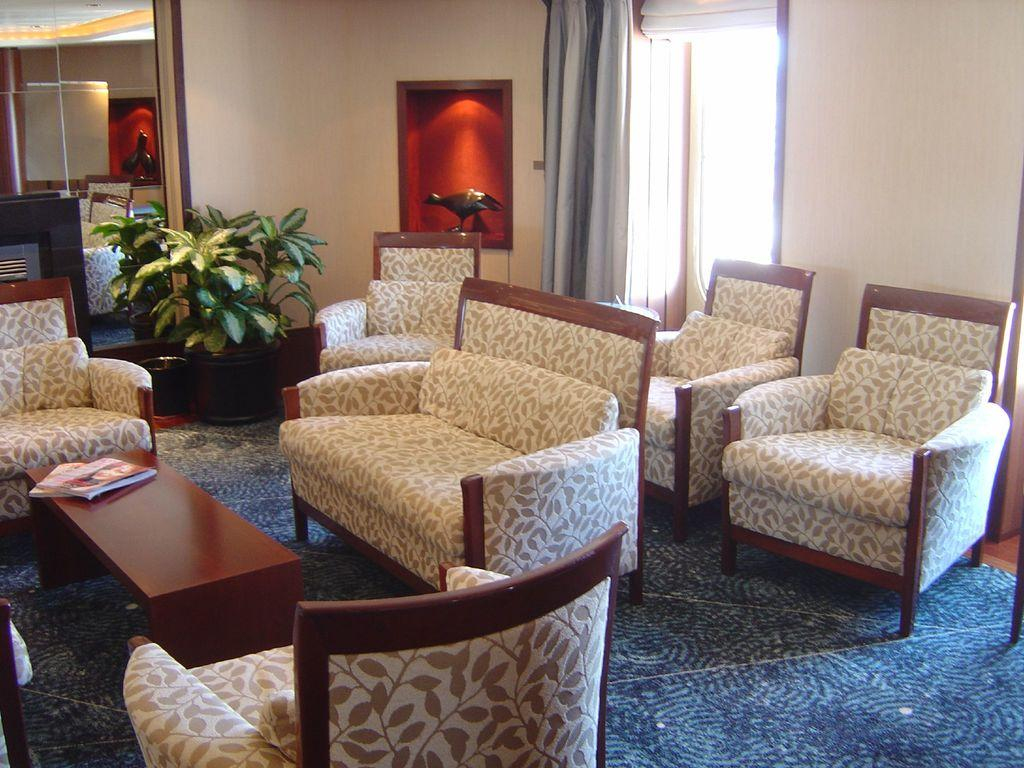What type of furniture is present in the image? There are sofa chairs in the image. What can be seen in the middle of the image? There is a plant in the middle of the image. Where is the window located in the image? The window is on the right side of the image. What type of flag is visible in the image? There is no flag present in the image. How many quivers can be seen in the image? There are no quivers present in the image. 